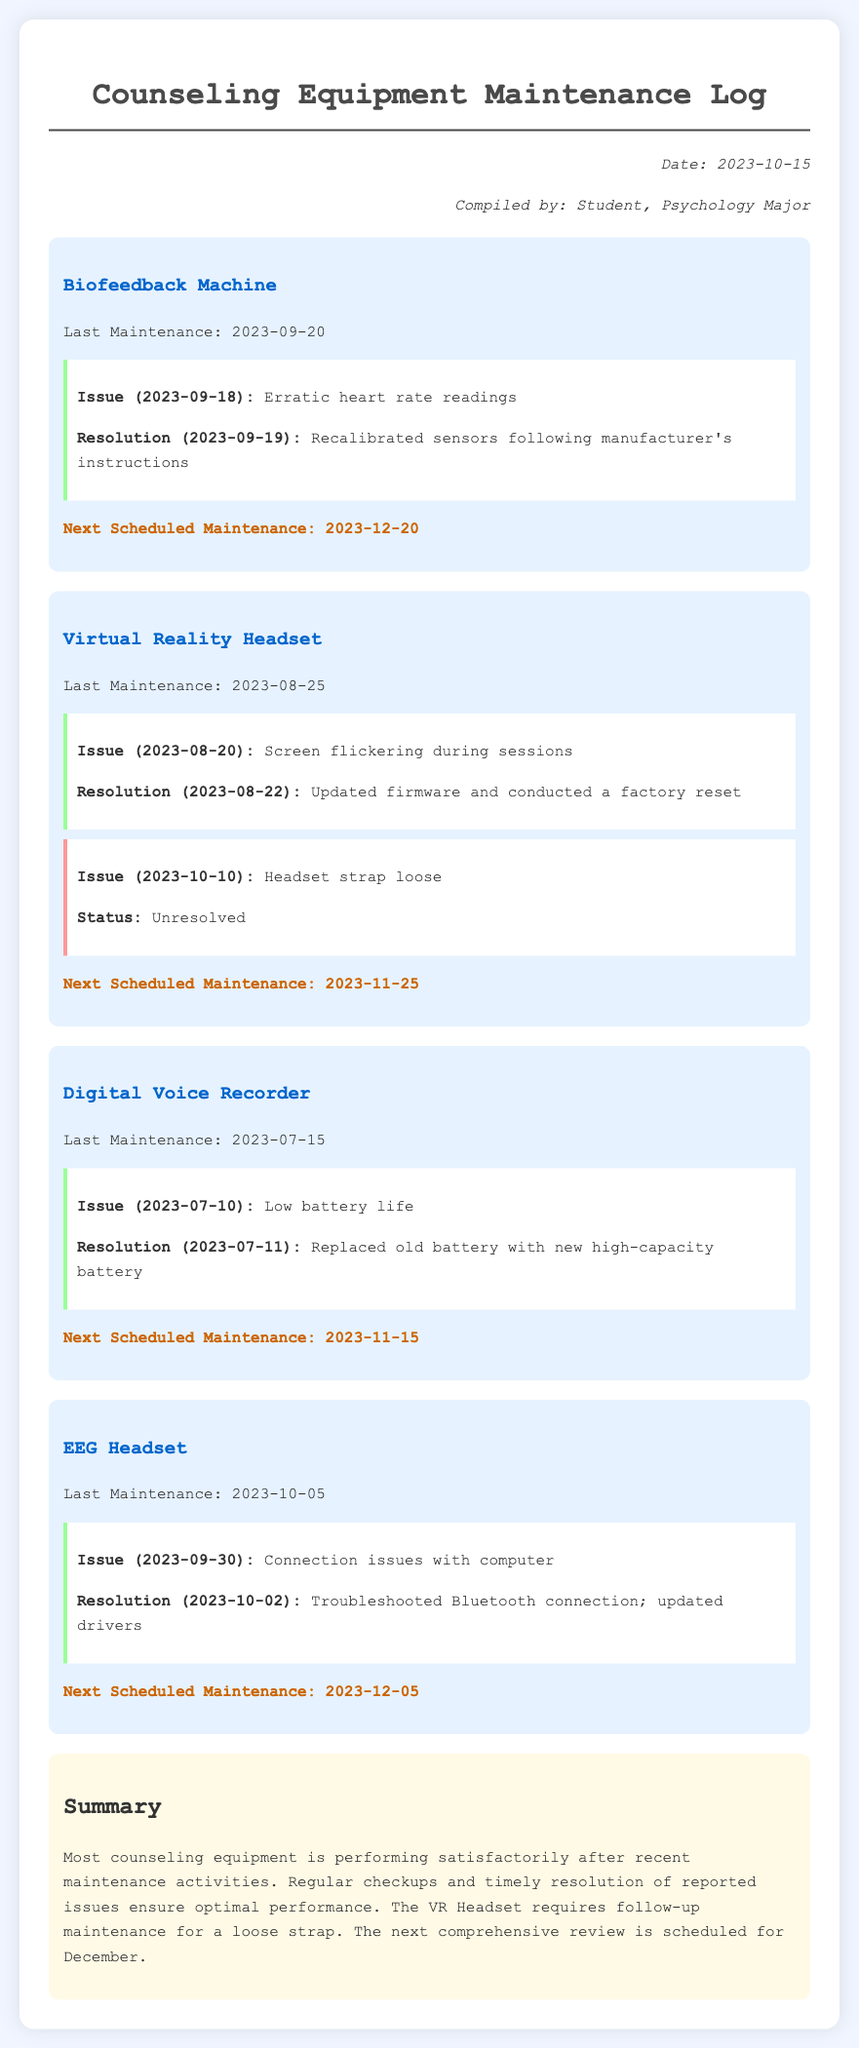What is the date of the last maintenance for the Biofeedback Machine? The last maintenance date for the Biofeedback Machine is mentioned in the document.
Answer: 2023-09-20 What is the issue reported for the Virtual Reality Headset on October 10, 2023? The reported issue on October 10, 2023, for the Virtual Reality Headset is listed in the document.
Answer: Headset strap loose When is the next scheduled maintenance for the Digital Voice Recorder? The document specifies the next scheduled maintenance date for the Digital Voice Recorder.
Answer: 2023-11-15 How many equipment items have unresolved issues? By reviewing the document, we can count the number of equipment items with unresolved issues.
Answer: 1 What was the resolution for the connection issues of the EEG Headset? The document provides the resolution for the reported connection issues with the EEG Headset.
Answer: Troubleshooted Bluetooth connection; updated drivers What color is used for the background of this maintenance log? This question targets the specific design aspect of the document instead of content.
Answer: Light blue What is the compiled date of this maintenance log? The compiled date is clearly stated in the document's meta information.
Answer: 2023-10-15 Which equipment item requires follow-up maintenance? The document mentions an equipment item that needs follow-up maintenance.
Answer: Virtual Reality Headset 